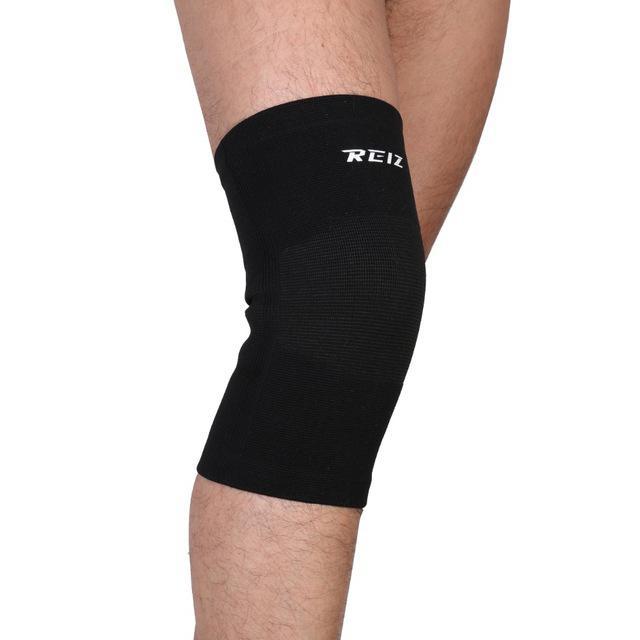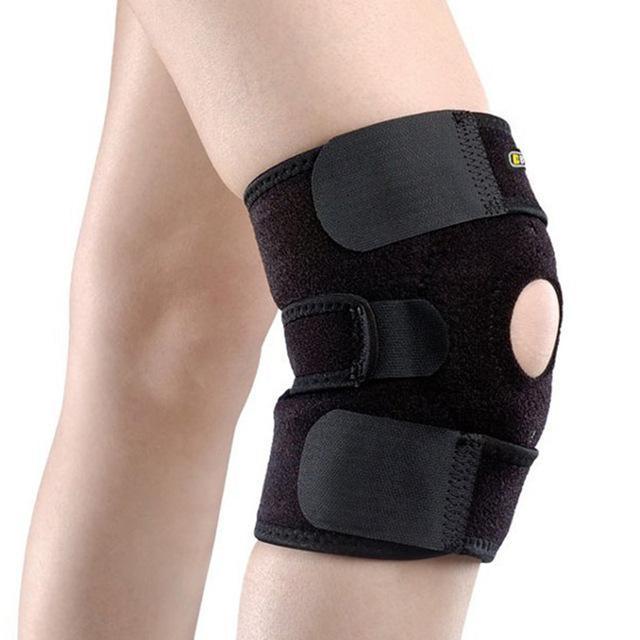The first image is the image on the left, the second image is the image on the right. For the images shown, is this caption "The left and right image contains a total of two knee braces." true? Answer yes or no. Yes. The first image is the image on the left, the second image is the image on the right. Analyze the images presented: Is the assertion "Each image shows a pair of legs, with just one leg wearing a black knee wrap." valid? Answer yes or no. Yes. 